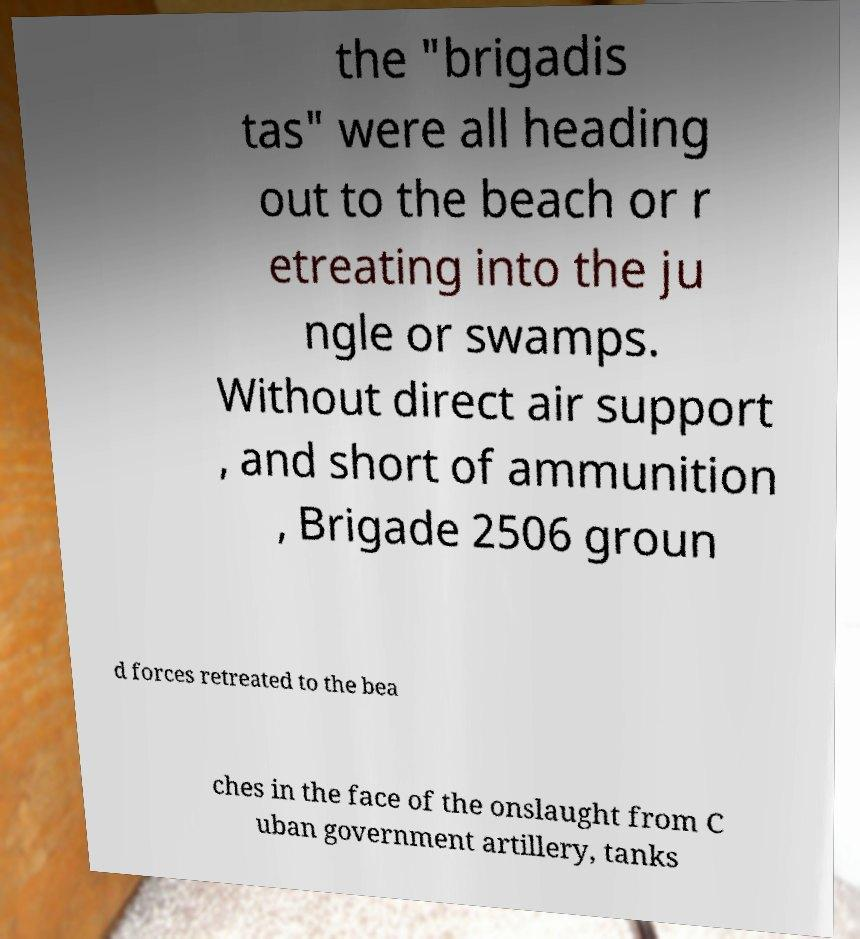For documentation purposes, I need the text within this image transcribed. Could you provide that? the "brigadis tas" were all heading out to the beach or r etreating into the ju ngle or swamps. Without direct air support , and short of ammunition , Brigade 2506 groun d forces retreated to the bea ches in the face of the onslaught from C uban government artillery, tanks 